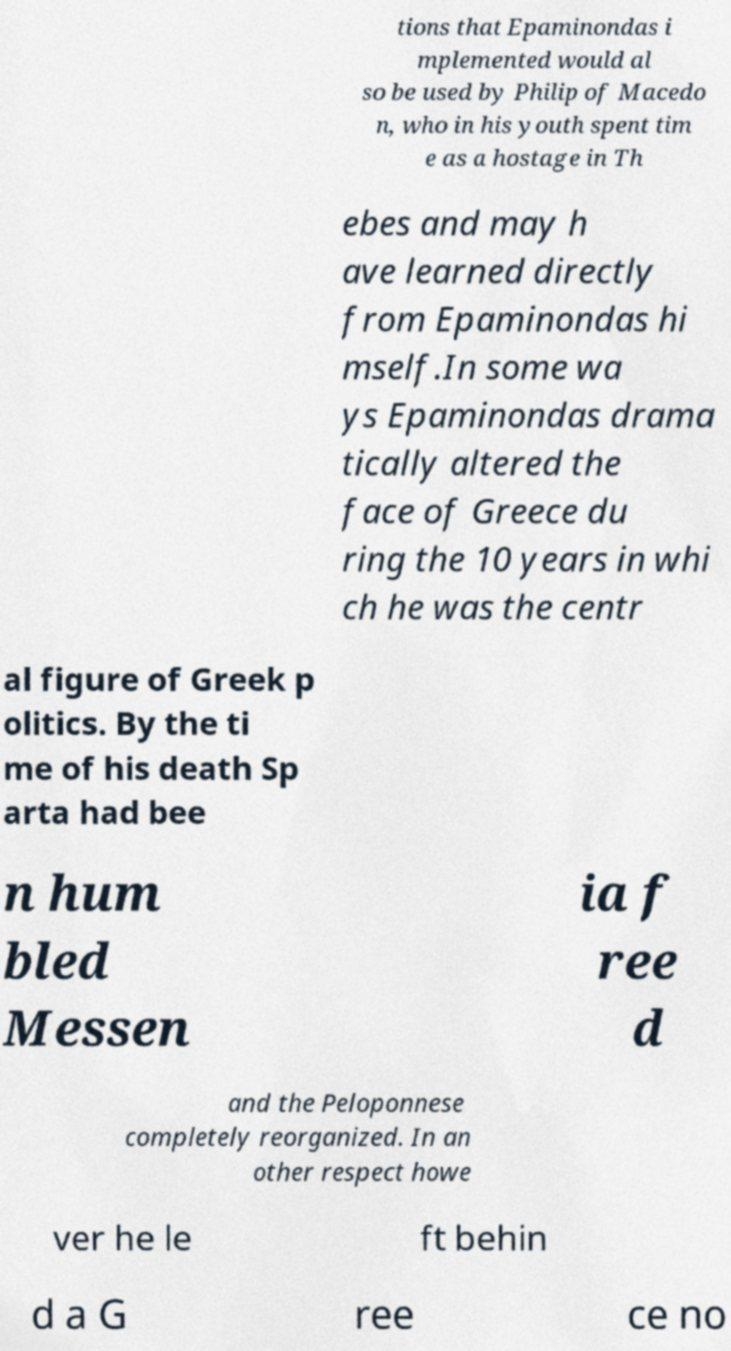Could you extract and type out the text from this image? tions that Epaminondas i mplemented would al so be used by Philip of Macedo n, who in his youth spent tim e as a hostage in Th ebes and may h ave learned directly from Epaminondas hi mself.In some wa ys Epaminondas drama tically altered the face of Greece du ring the 10 years in whi ch he was the centr al figure of Greek p olitics. By the ti me of his death Sp arta had bee n hum bled Messen ia f ree d and the Peloponnese completely reorganized. In an other respect howe ver he le ft behin d a G ree ce no 